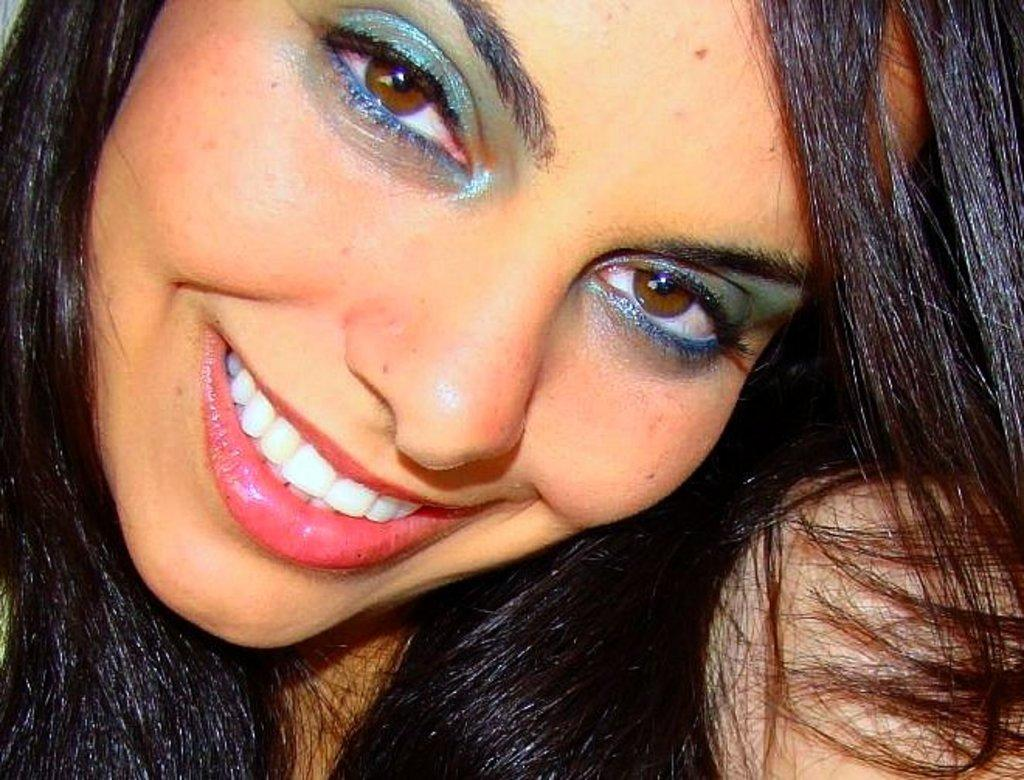What is the main subject of the image? The main subject of the image is a woman. Can you describe the woman's appearance? The woman has long hair. What type of map can be seen in the image? There is no map present in the image. 